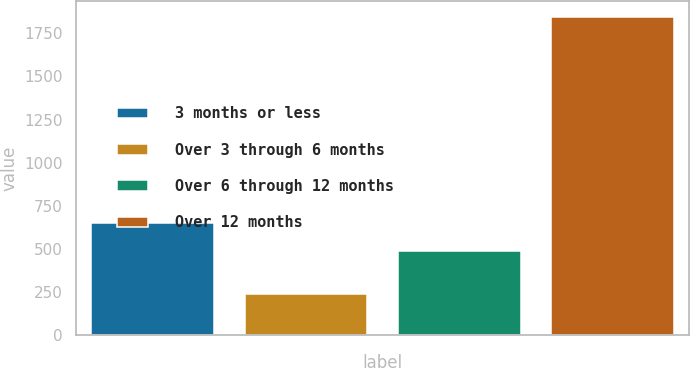<chart> <loc_0><loc_0><loc_500><loc_500><bar_chart><fcel>3 months or less<fcel>Over 3 through 6 months<fcel>Over 6 through 12 months<fcel>Over 12 months<nl><fcel>651.1<fcel>243<fcel>491<fcel>1844<nl></chart> 